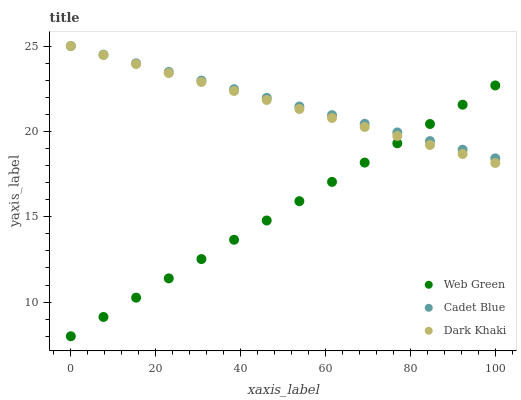Does Web Green have the minimum area under the curve?
Answer yes or no. Yes. Does Cadet Blue have the maximum area under the curve?
Answer yes or no. Yes. Does Cadet Blue have the minimum area under the curve?
Answer yes or no. No. Does Web Green have the maximum area under the curve?
Answer yes or no. No. Is Web Green the smoothest?
Answer yes or no. Yes. Is Dark Khaki the roughest?
Answer yes or no. Yes. Is Cadet Blue the smoothest?
Answer yes or no. No. Is Cadet Blue the roughest?
Answer yes or no. No. Does Web Green have the lowest value?
Answer yes or no. Yes. Does Cadet Blue have the lowest value?
Answer yes or no. No. Does Cadet Blue have the highest value?
Answer yes or no. Yes. Does Web Green have the highest value?
Answer yes or no. No. Does Web Green intersect Cadet Blue?
Answer yes or no. Yes. Is Web Green less than Cadet Blue?
Answer yes or no. No. Is Web Green greater than Cadet Blue?
Answer yes or no. No. 